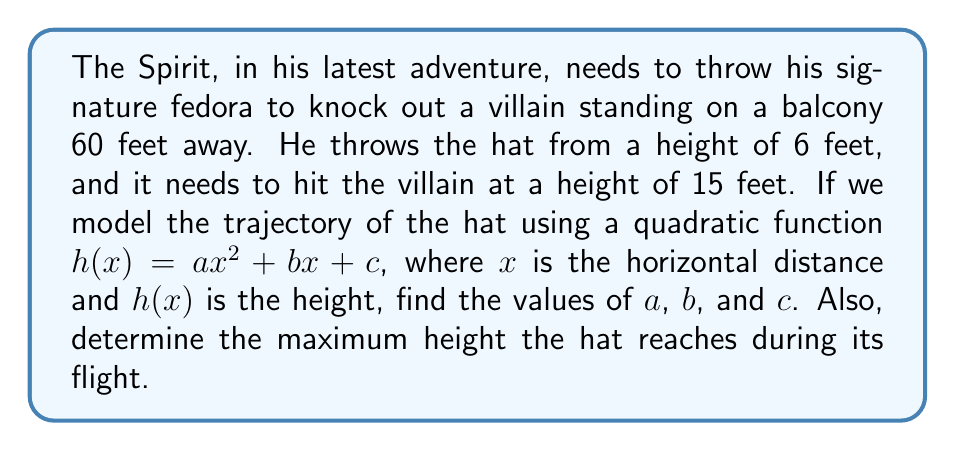Give your solution to this math problem. Let's approach this step-by-step:

1) We know three points on the trajectory:
   (0, 6) - starting point
   (60, 15) - ending point
   Let's call the vertex (p, q)

2) The general form of a quadratic function through these points is:
   $h(x) = a(x-p)^2 + q$

3) We can expand this to get:
   $h(x) = ax^2 - 2apx + ap^2 + q$

4) Comparing this with $h(x) = ax^2 + bx + c$, we see that:
   $b = -2ap$
   $c = ap^2 + q$

5) Now, let's use our known points:
   $6 = ap^2 + q$ (when x = 0)
   $15 = a(60-p)^2 + q$ (when x = 60)

6) Subtracting these equations:
   $9 = a(3600 - 120p + p^2)$

7) We also know that the axis of symmetry is halfway between 0 and 60:
   $p = 30$

8) Substituting this into the equation from step 6:
   $9 = a(3600 - 3600 + 900) = 900a$
   $a = 1/100$

9) Now we can find q:
   $6 = a(30)^2 + q$
   $6 = (1/100)(900) + q$
   $q = -3$

10) We can now find b and c:
    $b = -2ap = -2(1/100)(30) = -0.6$
    $c = ap^2 + q = (1/100)(900) - 3 = 6$

11) The maximum height occurs at the vertex (30, q):
    $h_{max} = -3 + 6 = 3$ feet above the starting height
    $3 + 6 = 9$ feet total
Answer: $a = 1/100$, $b = -0.6$, $c = 6$
The equation of the trajectory is $h(x) = \frac{1}{100}x^2 - 0.6x + 6$
The maximum height reached is 9 feet. 